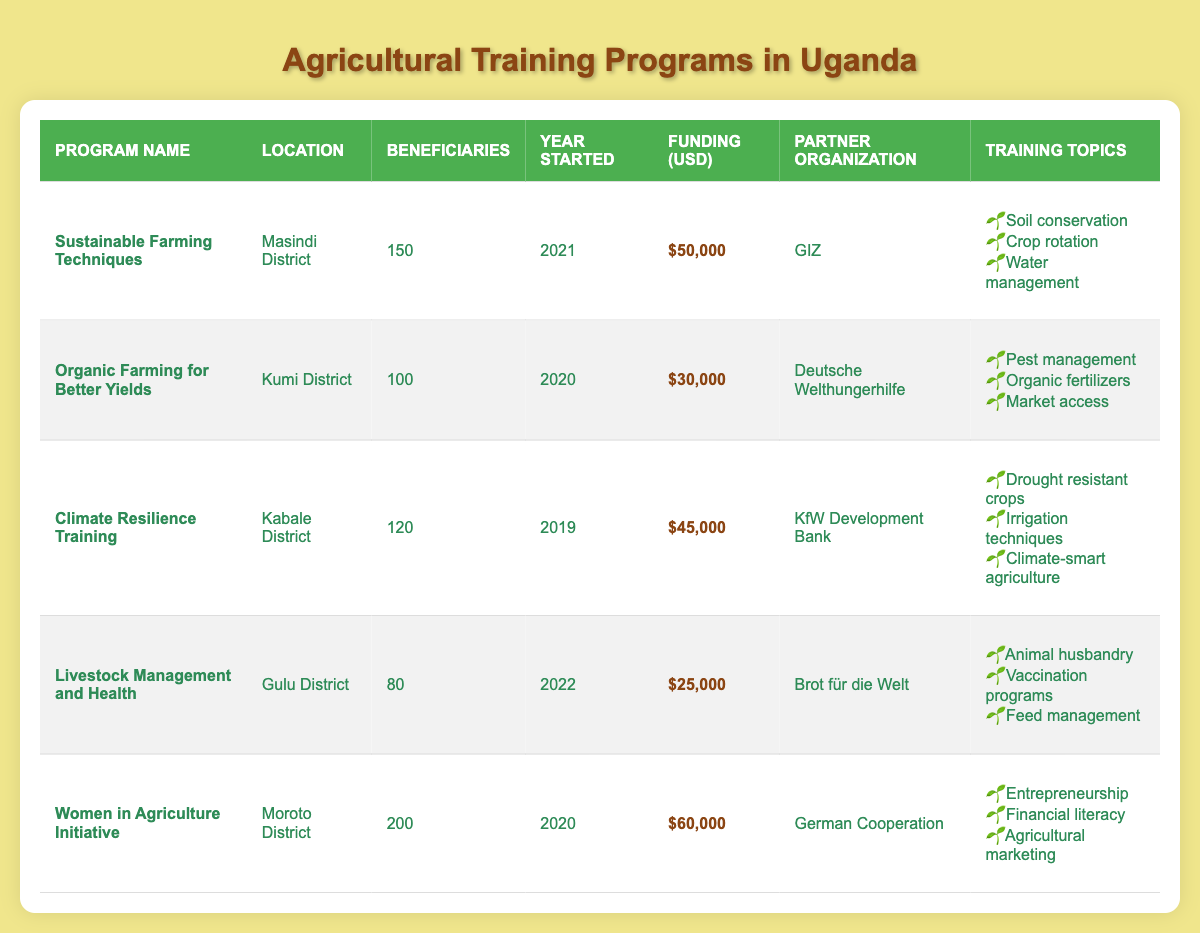What is the funding amount for the "Women in Agriculture Initiative"? The table lists the program "Women in Agriculture Initiative" with a funding amount of $60,000.
Answer: $60,000 Which program has the highest number of beneficiaries? By comparing the beneficiary counts, the "Women in Agriculture Initiative" has 200 beneficiaries, the most among all programs.
Answer: 200 What is the average funding amount of the agricultural training programs listed? The total funding amounts are $50,000 + $30,000 + $45,000 + $25,000 + $60,000 = $210,000. There are 5 programs, so the average funding is $210,000 / 5 = $42,000.
Answer: $42,000 Did the "Livestock Management and Health" program start in 2022? The "Livestock Management and Health" program started in 2022, confirming that the statement is accurate.
Answer: Yes How many total beneficiaries were served across all programs? The total number of beneficiaries is 150 (Masindi) + 100 (Kumi) + 120 (Kabale) + 80 (Gulu) + 200 (Moroto) = 650 beneficiaries.
Answer: 650 Which training topics are covered in the "Climate Resilience Training" program? The program "Climate Resilience Training" covers three topics: Drought resistant crops, Irrigation techniques, and Climate-smart agriculture.
Answer: Drought resistant crops, Irrigation techniques, Climate-smart agriculture Which partner organization funded the program with the least amount of funding? The program "Livestock Management and Health" has the least funding amount of $25,000, funded by Brot für die Welt.
Answer: Brot für die Welt Are there any programs located in the Kumi District? The table shows that there is one program, "Organic Farming for Better Yields," located in Kumi District, confirming the statement is true.
Answer: Yes What is the difference in funding between the "Sustainable Farming Techniques" and "Organic Farming for Better Yields" programs? The funding for "Sustainable Farming Techniques" is $50,000 and for "Organic Farming for Better Yields" is $30,000, thus the difference is $50,000 - $30,000 = $20,000.
Answer: $20,000 